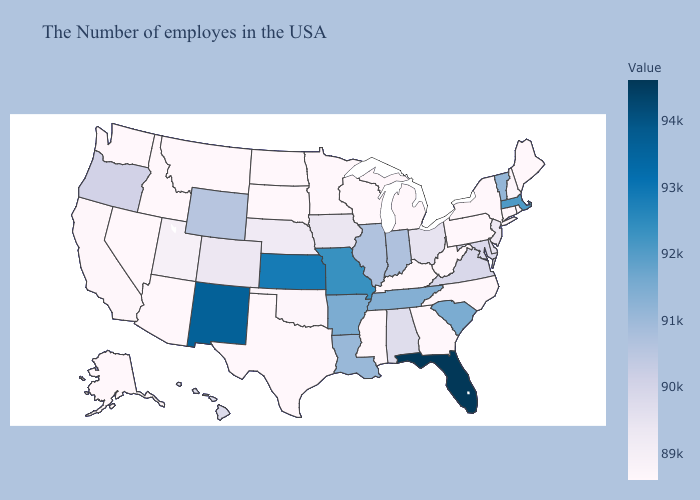Which states hav the highest value in the South?
Short answer required. Florida. Does Washington have the lowest value in the West?
Be succinct. Yes. Does Maine have the highest value in the Northeast?
Answer briefly. No. Among the states that border Wyoming , which have the highest value?
Keep it brief. Colorado. 